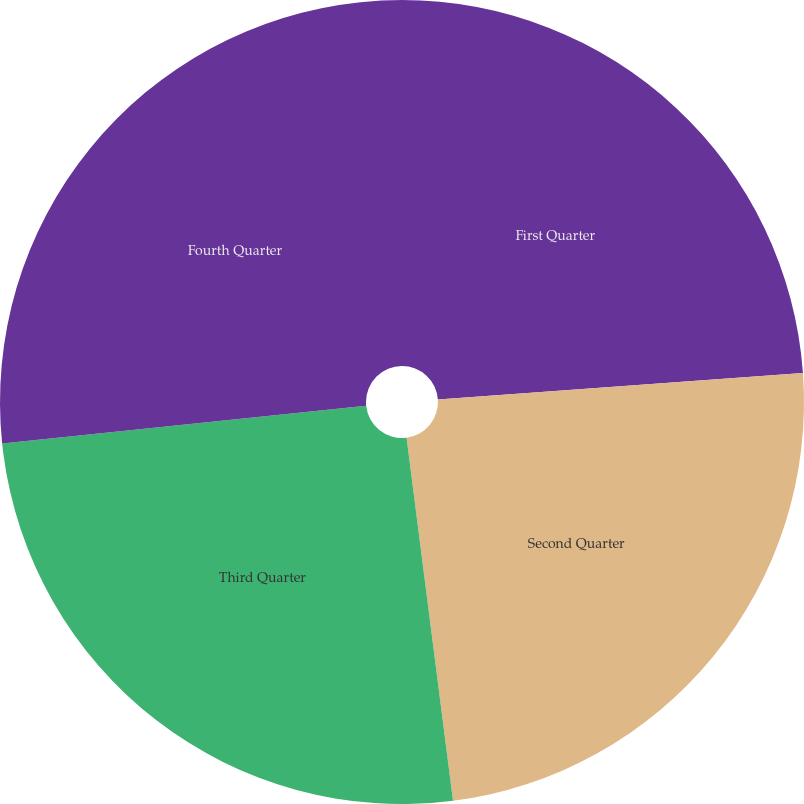Convert chart. <chart><loc_0><loc_0><loc_500><loc_500><pie_chart><fcel>First Quarter<fcel>Second Quarter<fcel>Third Quarter<fcel>Fourth Quarter<nl><fcel>23.85%<fcel>24.13%<fcel>25.38%<fcel>26.65%<nl></chart> 